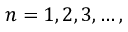<formula> <loc_0><loc_0><loc_500><loc_500>n = 1 , 2 , 3 , \dots ,</formula> 